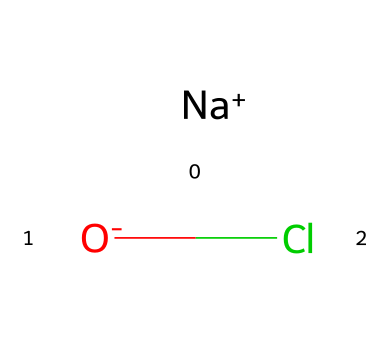What is the central atom in this chemical structure? The chemical structure shows chlorine (Cl) bonded to oxygen (O) and sodium (Na). Chlorine is the atom that is central to the hypochlorite ion.
Answer: chlorine How many atoms are present in this compound? In the chemical structure, there are three distinct atoms: one sodium (Na), one oxygen (O), and one chlorine (Cl), making a total of three atoms.
Answer: three What type of bond exists between oxygen and chlorine? The structure indicates an ionic bond due to the presence of sodium cation and hypochlorite anion, suggesting that the bond between oxygen and chlorine is covalent.
Answer: covalent What is the charge of the sodium ion in this structure? The chemical representation indicates that sodium (Na) is present as a cation with a charge of +1, represented as [Na+].
Answer: plus one What type of chemical is sodium hypochlorite classified as? Sodium hypochlorite consists of a halogen (chlorine), and since it is based on hypochlorite, it is classified as a halogen compound.
Answer: halogen compound Is the oxygen in this compound negatively charged? Yes, in the chemical structure the oxygen is indicated with a charge of -1 (O-), meaning it has gained an electron, thus becoming negatively charged.
Answer: yes What property does this compound often provide when used in household applications? Sodium hypochlorite is well-known for its disinfecting properties, often used in household bleach to eliminate bacteria and other pathogens.
Answer: disinfectant 